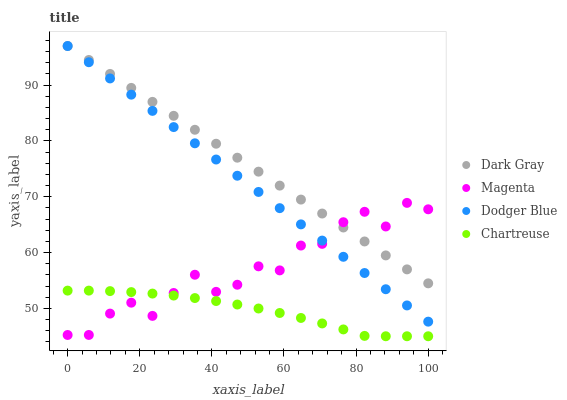Does Chartreuse have the minimum area under the curve?
Answer yes or no. Yes. Does Dark Gray have the maximum area under the curve?
Answer yes or no. Yes. Does Magenta have the minimum area under the curve?
Answer yes or no. No. Does Magenta have the maximum area under the curve?
Answer yes or no. No. Is Dodger Blue the smoothest?
Answer yes or no. Yes. Is Magenta the roughest?
Answer yes or no. Yes. Is Magenta the smoothest?
Answer yes or no. No. Is Dodger Blue the roughest?
Answer yes or no. No. Does Chartreuse have the lowest value?
Answer yes or no. Yes. Does Magenta have the lowest value?
Answer yes or no. No. Does Dodger Blue have the highest value?
Answer yes or no. Yes. Does Magenta have the highest value?
Answer yes or no. No. Is Chartreuse less than Dark Gray?
Answer yes or no. Yes. Is Dodger Blue greater than Chartreuse?
Answer yes or no. Yes. Does Magenta intersect Chartreuse?
Answer yes or no. Yes. Is Magenta less than Chartreuse?
Answer yes or no. No. Is Magenta greater than Chartreuse?
Answer yes or no. No. Does Chartreuse intersect Dark Gray?
Answer yes or no. No. 